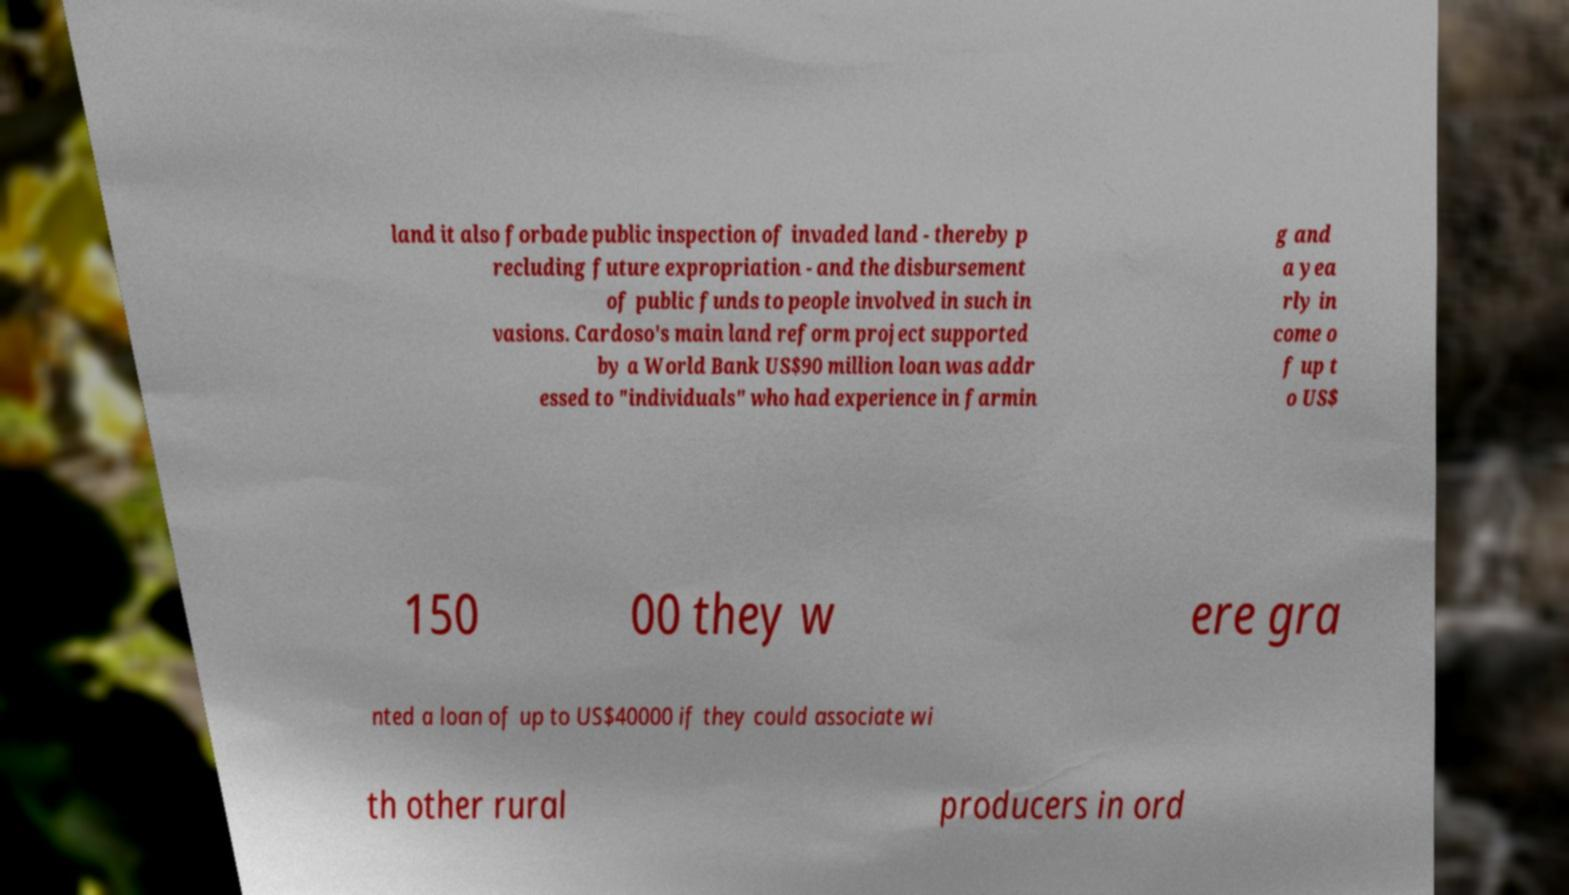Please read and relay the text visible in this image. What does it say? land it also forbade public inspection of invaded land - thereby p recluding future expropriation - and the disbursement of public funds to people involved in such in vasions. Cardoso's main land reform project supported by a World Bank US$90 million loan was addr essed to "individuals" who had experience in farmin g and a yea rly in come o f up t o US$ 150 00 they w ere gra nted a loan of up to US$40000 if they could associate wi th other rural producers in ord 